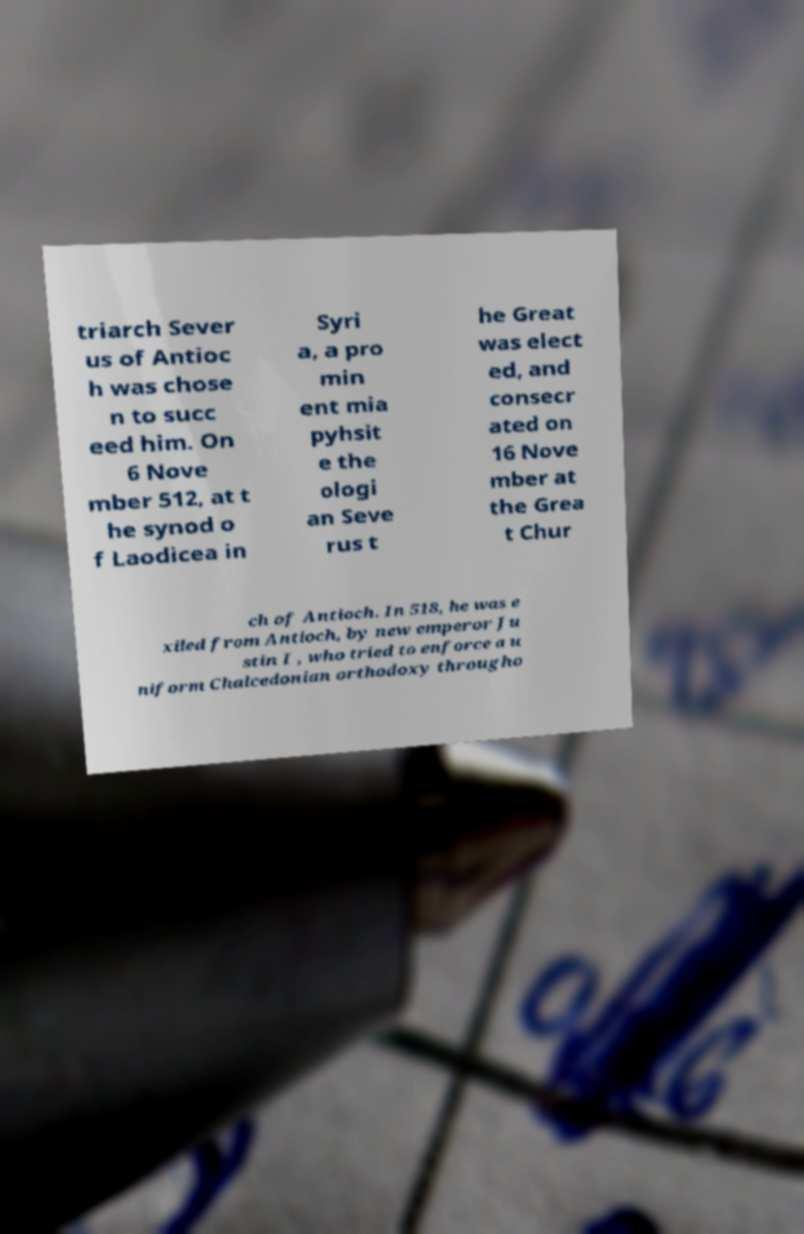What messages or text are displayed in this image? I need them in a readable, typed format. triarch Sever us of Antioc h was chose n to succ eed him. On 6 Nove mber 512, at t he synod o f Laodicea in Syri a, a pro min ent mia pyhsit e the ologi an Seve rus t he Great was elect ed, and consecr ated on 16 Nove mber at the Grea t Chur ch of Antioch. In 518, he was e xiled from Antioch, by new emperor Ju stin I , who tried to enforce a u niform Chalcedonian orthodoxy througho 